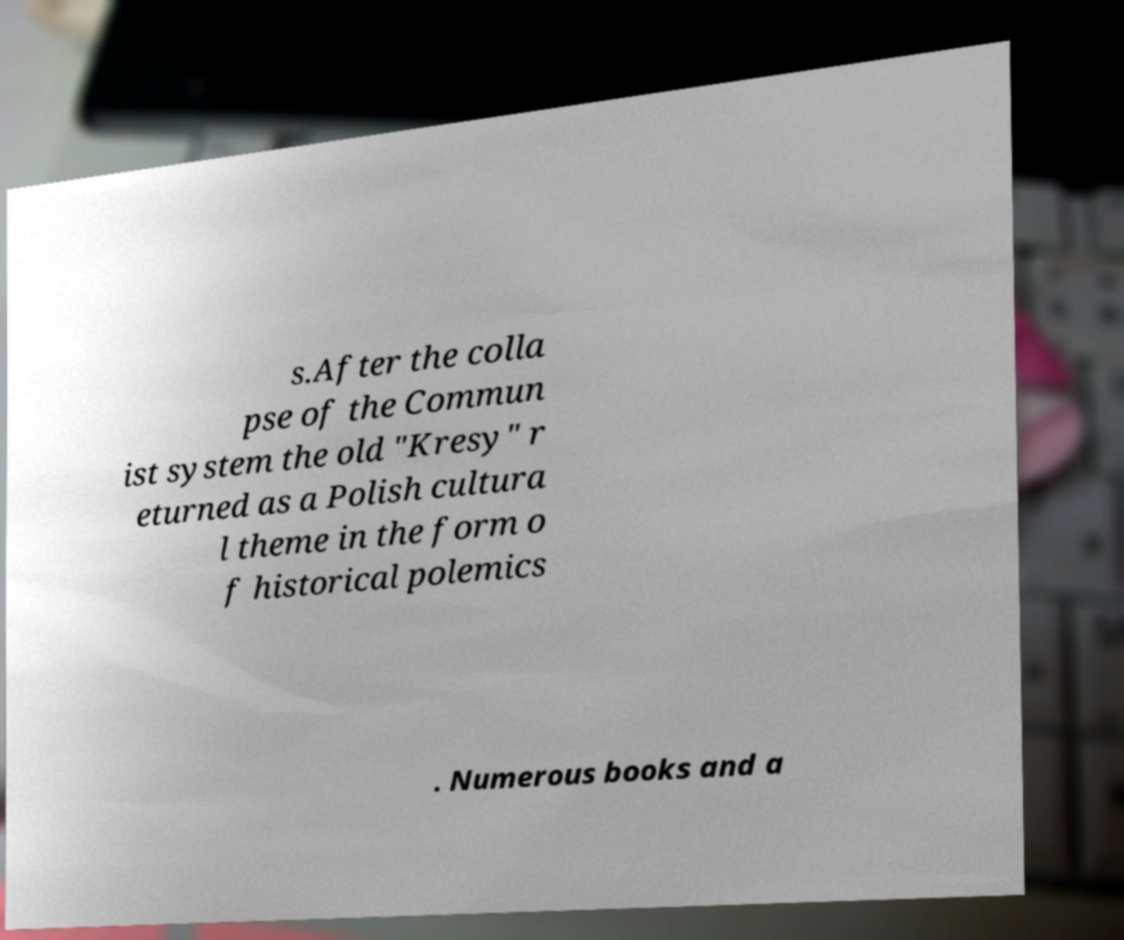What messages or text are displayed in this image? I need them in a readable, typed format. s.After the colla pse of the Commun ist system the old "Kresy" r eturned as a Polish cultura l theme in the form o f historical polemics . Numerous books and a 